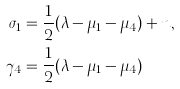Convert formula to latex. <formula><loc_0><loc_0><loc_500><loc_500>\sigma _ { 1 } & = \frac { 1 } { 2 } ( \lambda - \mu _ { 1 } - \mu _ { 4 } ) + n , \\ \gamma _ { 4 } & = \frac { 1 } { 2 } ( \lambda - \mu _ { 1 } - \mu _ { 4 } )</formula> 